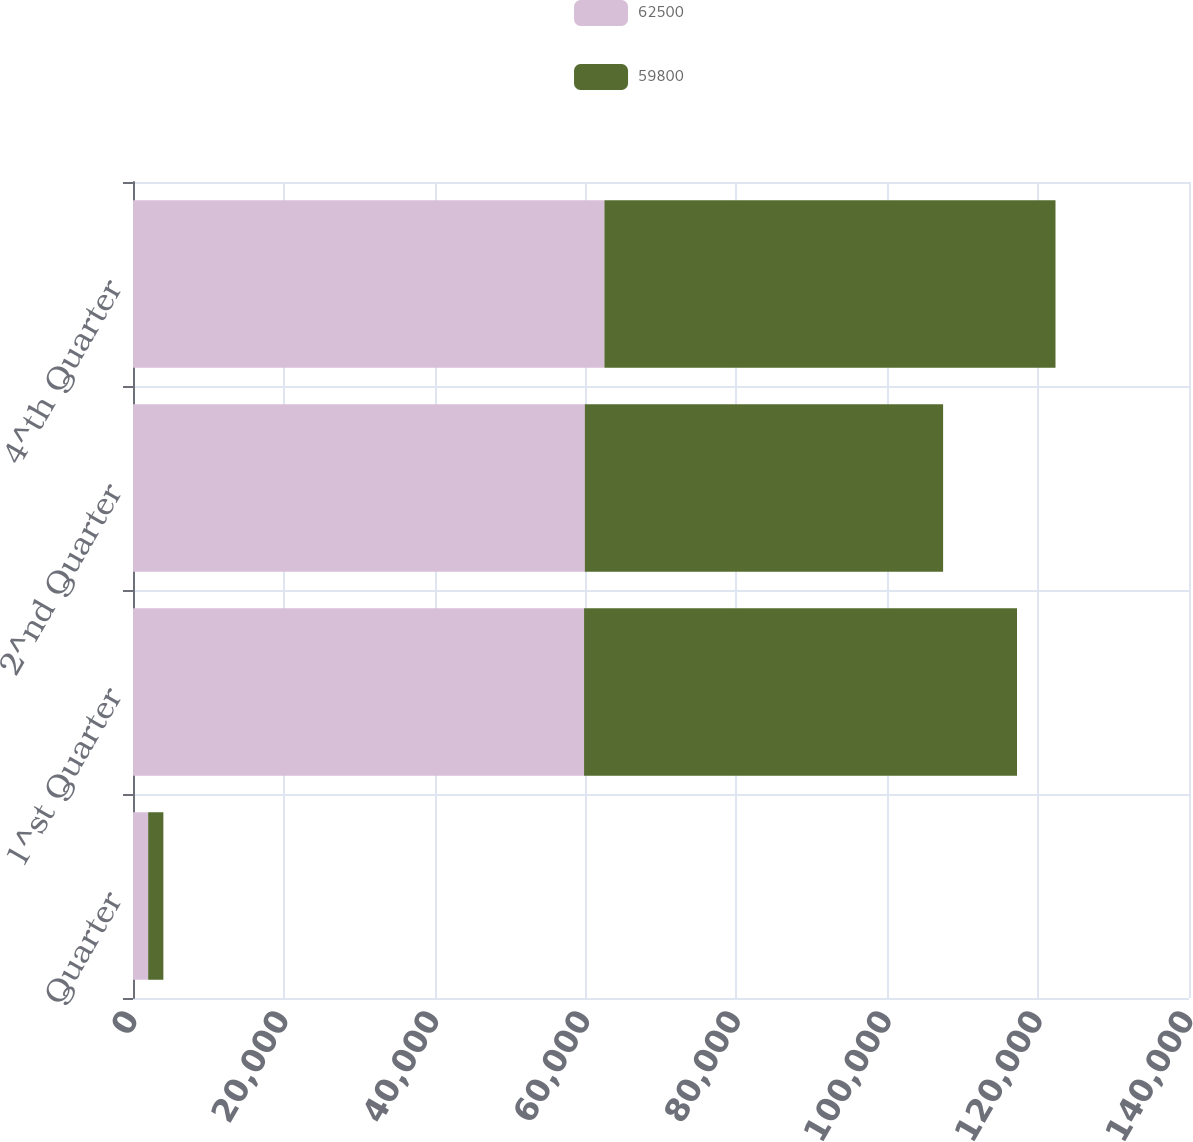Convert chart. <chart><loc_0><loc_0><loc_500><loc_500><stacked_bar_chart><ecel><fcel>Quarter<fcel>1^st Quarter<fcel>2^nd Quarter<fcel>4^th Quarter<nl><fcel>62500<fcel>2013<fcel>59800<fcel>59900<fcel>62500<nl><fcel>59800<fcel>2012<fcel>57400<fcel>47500<fcel>59800<nl></chart> 